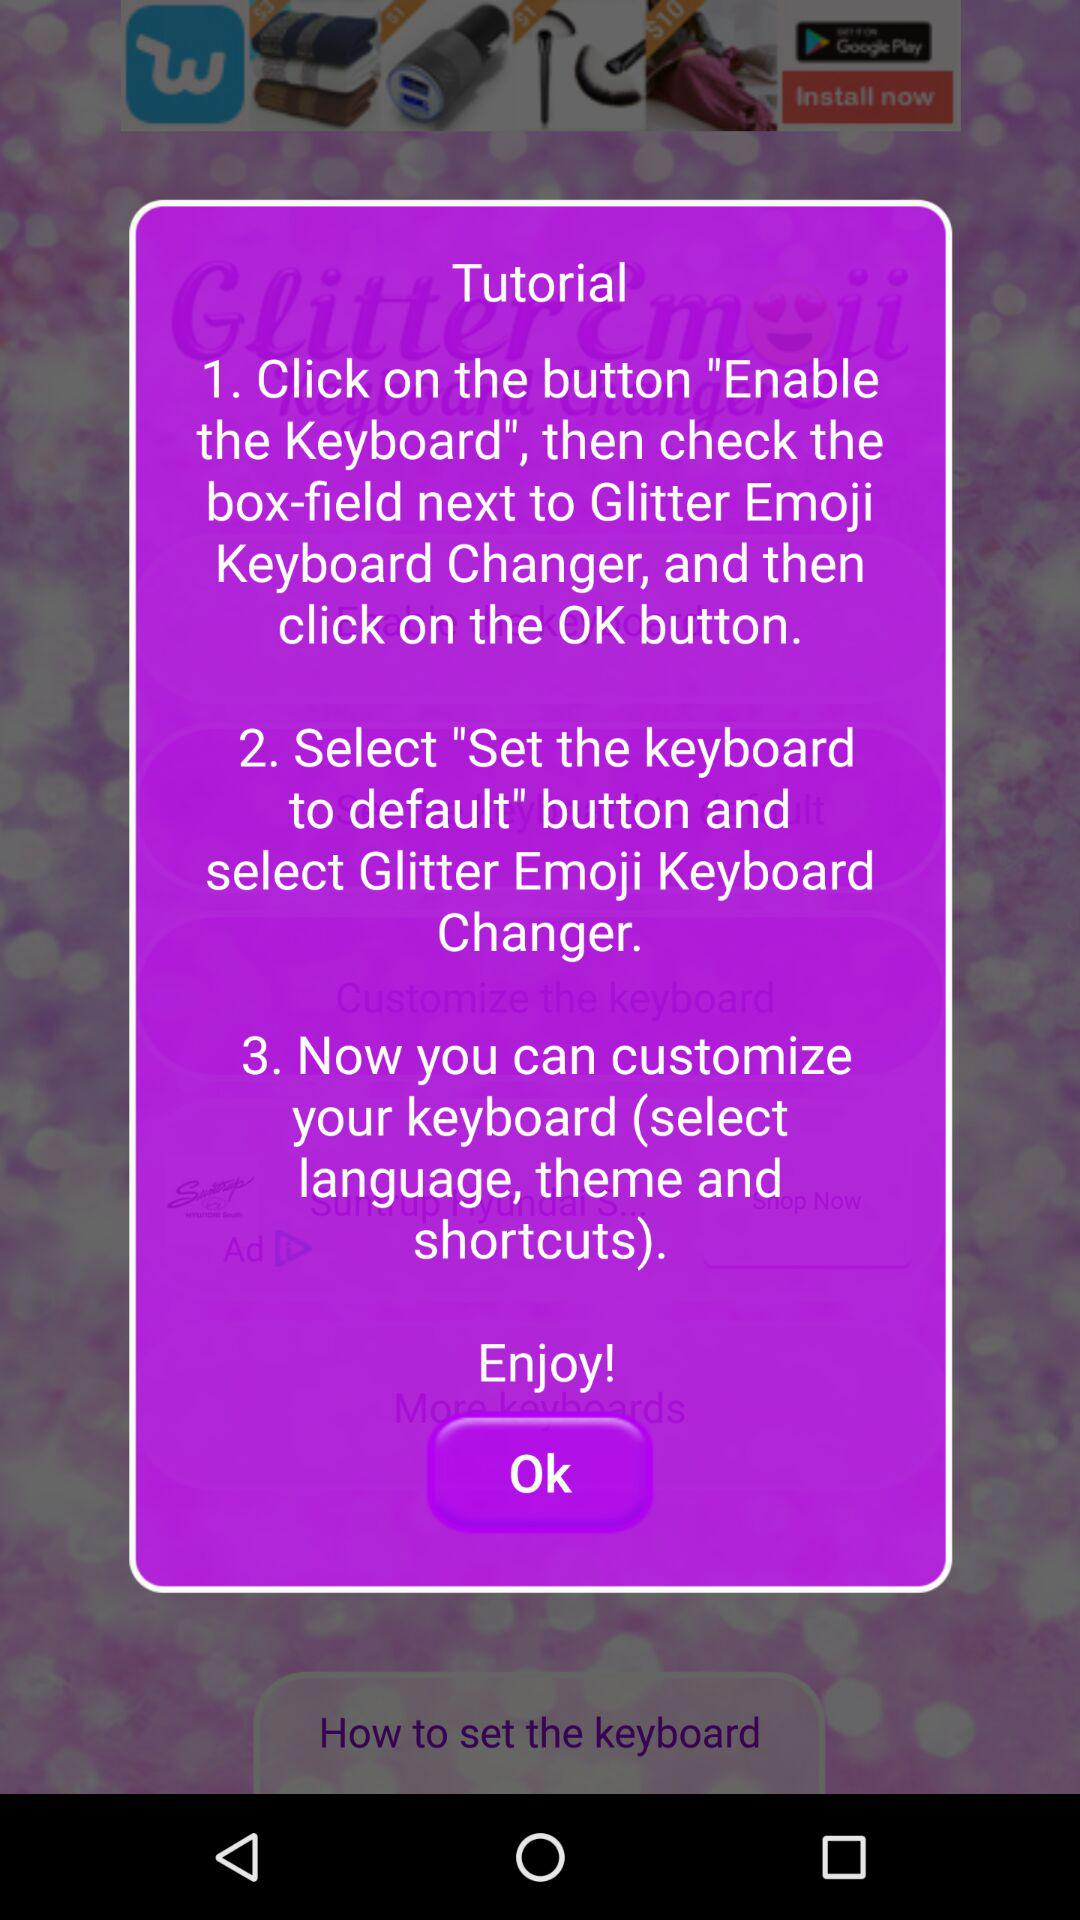What is the count of the total steps given?
When the provided information is insufficient, respond with <no answer>. <no answer> 